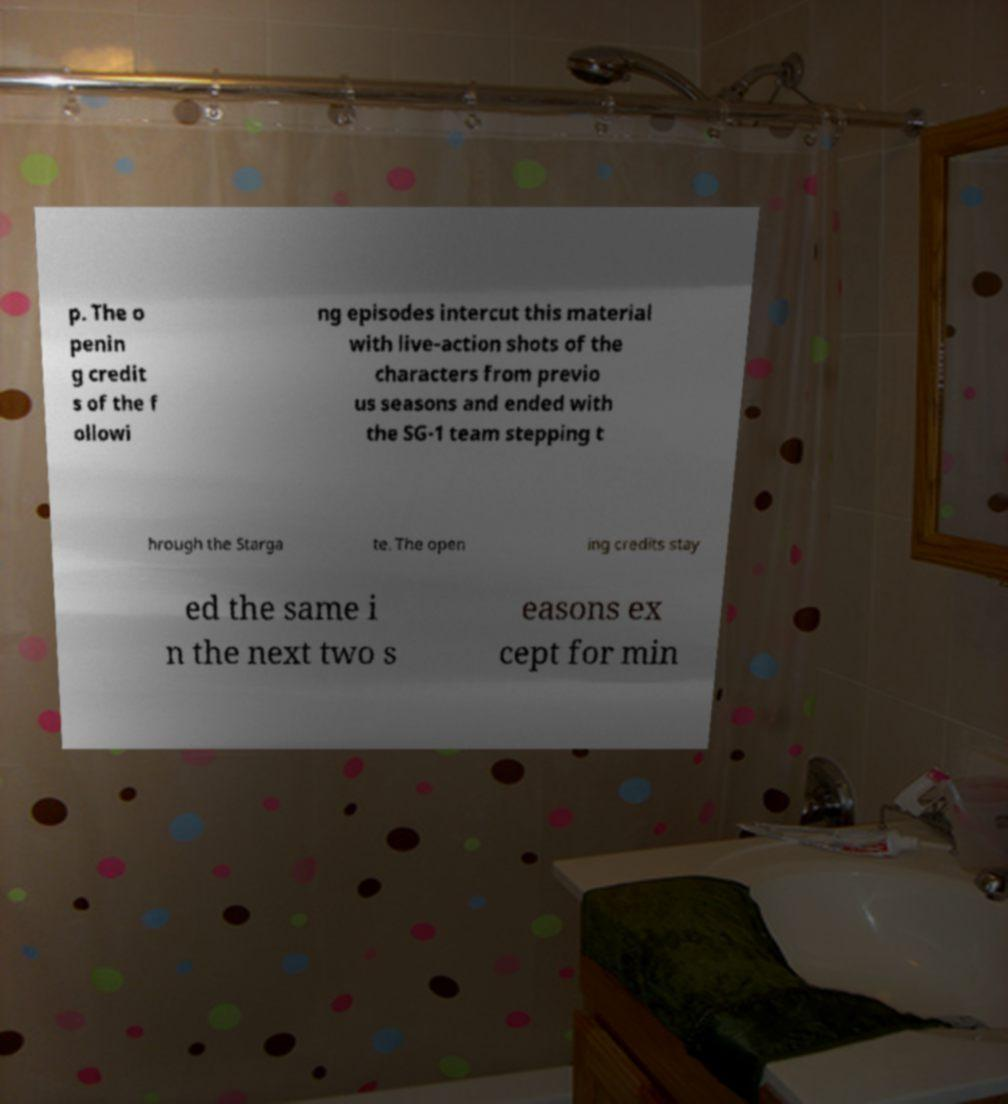There's text embedded in this image that I need extracted. Can you transcribe it verbatim? p. The o penin g credit s of the f ollowi ng episodes intercut this material with live-action shots of the characters from previo us seasons and ended with the SG-1 team stepping t hrough the Starga te. The open ing credits stay ed the same i n the next two s easons ex cept for min 